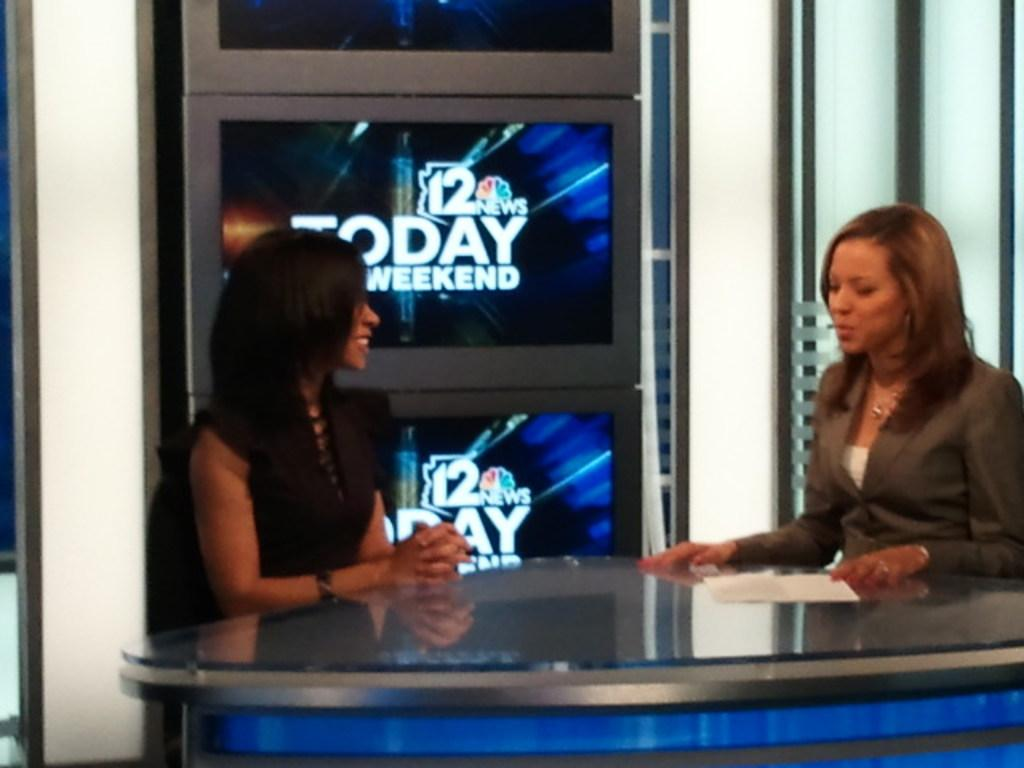<image>
Present a compact description of the photo's key features. two woman commentators at the channel 12 today weekend show 